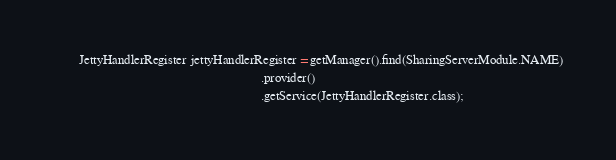Convert code to text. <code><loc_0><loc_0><loc_500><loc_500><_Java_>        JettyHandlerRegister jettyHandlerRegister = getManager().find(SharingServerModule.NAME)
                                                                .provider()
                                                                .getService(JettyHandlerRegister.class);</code> 